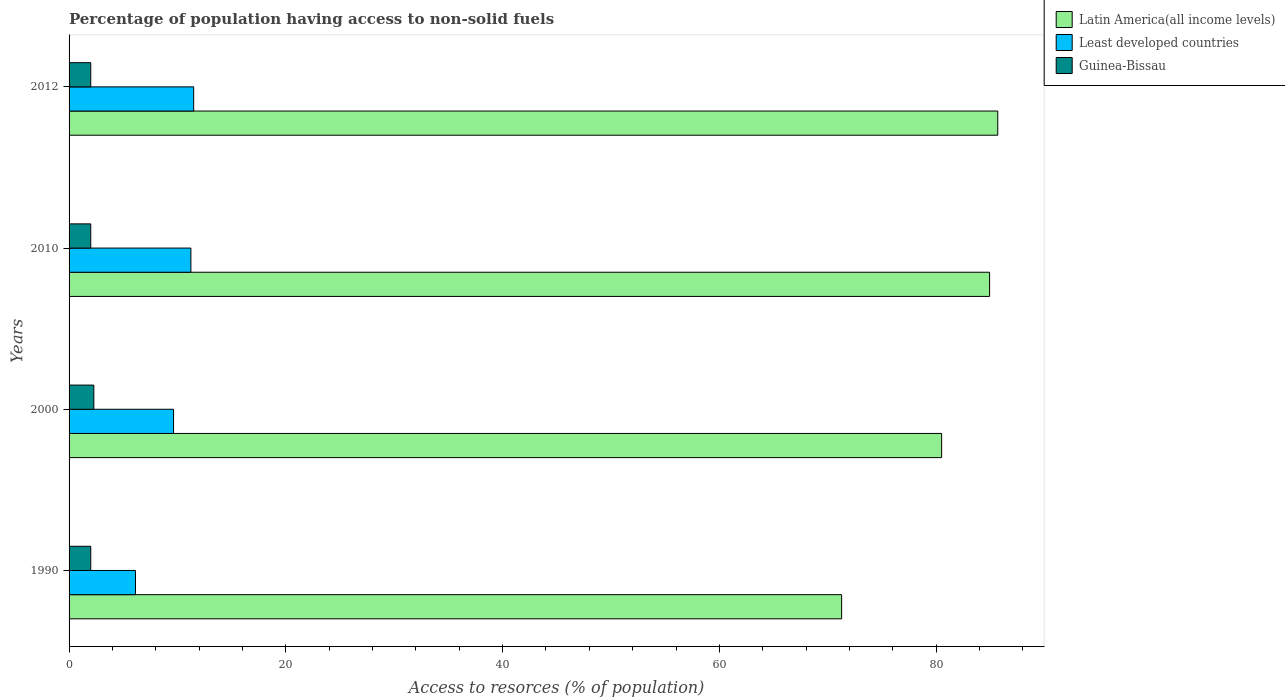How many groups of bars are there?
Keep it short and to the point. 4. Are the number of bars per tick equal to the number of legend labels?
Offer a very short reply. Yes. How many bars are there on the 3rd tick from the top?
Ensure brevity in your answer.  3. What is the label of the 2nd group of bars from the top?
Your answer should be compact. 2010. What is the percentage of population having access to non-solid fuels in Latin America(all income levels) in 2012?
Give a very brief answer. 85.68. Across all years, what is the maximum percentage of population having access to non-solid fuels in Least developed countries?
Your answer should be very brief. 11.5. Across all years, what is the minimum percentage of population having access to non-solid fuels in Least developed countries?
Offer a very short reply. 6.13. In which year was the percentage of population having access to non-solid fuels in Least developed countries minimum?
Your answer should be compact. 1990. What is the total percentage of population having access to non-solid fuels in Guinea-Bissau in the graph?
Make the answer very short. 8.28. What is the difference between the percentage of population having access to non-solid fuels in Latin America(all income levels) in 2010 and that in 2012?
Offer a terse response. -0.75. What is the difference between the percentage of population having access to non-solid fuels in Guinea-Bissau in 2000 and the percentage of population having access to non-solid fuels in Latin America(all income levels) in 2012?
Offer a terse response. -83.4. What is the average percentage of population having access to non-solid fuels in Guinea-Bissau per year?
Give a very brief answer. 2.07. In the year 2000, what is the difference between the percentage of population having access to non-solid fuels in Guinea-Bissau and percentage of population having access to non-solid fuels in Latin America(all income levels)?
Your response must be concise. -78.22. What is the ratio of the percentage of population having access to non-solid fuels in Latin America(all income levels) in 2010 to that in 2012?
Make the answer very short. 0.99. What is the difference between the highest and the second highest percentage of population having access to non-solid fuels in Latin America(all income levels)?
Offer a very short reply. 0.75. What is the difference between the highest and the lowest percentage of population having access to non-solid fuels in Least developed countries?
Your answer should be very brief. 5.37. Is the sum of the percentage of population having access to non-solid fuels in Least developed countries in 1990 and 2000 greater than the maximum percentage of population having access to non-solid fuels in Latin America(all income levels) across all years?
Provide a succinct answer. No. What does the 1st bar from the top in 2010 represents?
Make the answer very short. Guinea-Bissau. What does the 1st bar from the bottom in 2012 represents?
Ensure brevity in your answer.  Latin America(all income levels). How many bars are there?
Make the answer very short. 12. Where does the legend appear in the graph?
Your answer should be very brief. Top right. What is the title of the graph?
Provide a succinct answer. Percentage of population having access to non-solid fuels. Does "East Asia (developing only)" appear as one of the legend labels in the graph?
Make the answer very short. No. What is the label or title of the X-axis?
Your answer should be compact. Access to resorces (% of population). What is the label or title of the Y-axis?
Offer a very short reply. Years. What is the Access to resorces (% of population) in Latin America(all income levels) in 1990?
Offer a very short reply. 71.28. What is the Access to resorces (% of population) in Least developed countries in 1990?
Keep it short and to the point. 6.13. What is the Access to resorces (% of population) in Guinea-Bissau in 1990?
Ensure brevity in your answer.  2. What is the Access to resorces (% of population) in Latin America(all income levels) in 2000?
Provide a short and direct response. 80.51. What is the Access to resorces (% of population) of Least developed countries in 2000?
Give a very brief answer. 9.64. What is the Access to resorces (% of population) of Guinea-Bissau in 2000?
Offer a very short reply. 2.28. What is the Access to resorces (% of population) of Latin America(all income levels) in 2010?
Ensure brevity in your answer.  84.93. What is the Access to resorces (% of population) of Least developed countries in 2010?
Ensure brevity in your answer.  11.24. What is the Access to resorces (% of population) of Guinea-Bissau in 2010?
Provide a succinct answer. 2. What is the Access to resorces (% of population) in Latin America(all income levels) in 2012?
Offer a terse response. 85.68. What is the Access to resorces (% of population) of Least developed countries in 2012?
Provide a short and direct response. 11.5. What is the Access to resorces (% of population) of Guinea-Bissau in 2012?
Offer a terse response. 2. Across all years, what is the maximum Access to resorces (% of population) of Latin America(all income levels)?
Your response must be concise. 85.68. Across all years, what is the maximum Access to resorces (% of population) of Least developed countries?
Ensure brevity in your answer.  11.5. Across all years, what is the maximum Access to resorces (% of population) in Guinea-Bissau?
Keep it short and to the point. 2.28. Across all years, what is the minimum Access to resorces (% of population) in Latin America(all income levels)?
Ensure brevity in your answer.  71.28. Across all years, what is the minimum Access to resorces (% of population) of Least developed countries?
Offer a very short reply. 6.13. Across all years, what is the minimum Access to resorces (% of population) in Guinea-Bissau?
Keep it short and to the point. 2. What is the total Access to resorces (% of population) of Latin America(all income levels) in the graph?
Give a very brief answer. 322.4. What is the total Access to resorces (% of population) of Least developed countries in the graph?
Ensure brevity in your answer.  38.5. What is the total Access to resorces (% of population) in Guinea-Bissau in the graph?
Your answer should be compact. 8.28. What is the difference between the Access to resorces (% of population) of Latin America(all income levels) in 1990 and that in 2000?
Give a very brief answer. -9.23. What is the difference between the Access to resorces (% of population) in Least developed countries in 1990 and that in 2000?
Your response must be concise. -3.51. What is the difference between the Access to resorces (% of population) in Guinea-Bissau in 1990 and that in 2000?
Offer a very short reply. -0.28. What is the difference between the Access to resorces (% of population) of Latin America(all income levels) in 1990 and that in 2010?
Ensure brevity in your answer.  -13.65. What is the difference between the Access to resorces (% of population) of Least developed countries in 1990 and that in 2010?
Provide a short and direct response. -5.11. What is the difference between the Access to resorces (% of population) of Latin America(all income levels) in 1990 and that in 2012?
Offer a terse response. -14.41. What is the difference between the Access to resorces (% of population) of Least developed countries in 1990 and that in 2012?
Make the answer very short. -5.37. What is the difference between the Access to resorces (% of population) in Guinea-Bissau in 1990 and that in 2012?
Provide a short and direct response. 0. What is the difference between the Access to resorces (% of population) of Latin America(all income levels) in 2000 and that in 2010?
Provide a succinct answer. -4.43. What is the difference between the Access to resorces (% of population) of Least developed countries in 2000 and that in 2010?
Offer a terse response. -1.6. What is the difference between the Access to resorces (% of population) of Guinea-Bissau in 2000 and that in 2010?
Provide a short and direct response. 0.28. What is the difference between the Access to resorces (% of population) of Latin America(all income levels) in 2000 and that in 2012?
Ensure brevity in your answer.  -5.18. What is the difference between the Access to resorces (% of population) of Least developed countries in 2000 and that in 2012?
Give a very brief answer. -1.86. What is the difference between the Access to resorces (% of population) of Guinea-Bissau in 2000 and that in 2012?
Keep it short and to the point. 0.28. What is the difference between the Access to resorces (% of population) in Latin America(all income levels) in 2010 and that in 2012?
Offer a terse response. -0.75. What is the difference between the Access to resorces (% of population) of Least developed countries in 2010 and that in 2012?
Your answer should be very brief. -0.26. What is the difference between the Access to resorces (% of population) of Guinea-Bissau in 2010 and that in 2012?
Give a very brief answer. 0. What is the difference between the Access to resorces (% of population) in Latin America(all income levels) in 1990 and the Access to resorces (% of population) in Least developed countries in 2000?
Your answer should be compact. 61.64. What is the difference between the Access to resorces (% of population) in Latin America(all income levels) in 1990 and the Access to resorces (% of population) in Guinea-Bissau in 2000?
Offer a very short reply. 68.99. What is the difference between the Access to resorces (% of population) of Least developed countries in 1990 and the Access to resorces (% of population) of Guinea-Bissau in 2000?
Keep it short and to the point. 3.84. What is the difference between the Access to resorces (% of population) in Latin America(all income levels) in 1990 and the Access to resorces (% of population) in Least developed countries in 2010?
Provide a succinct answer. 60.04. What is the difference between the Access to resorces (% of population) of Latin America(all income levels) in 1990 and the Access to resorces (% of population) of Guinea-Bissau in 2010?
Give a very brief answer. 69.28. What is the difference between the Access to resorces (% of population) of Least developed countries in 1990 and the Access to resorces (% of population) of Guinea-Bissau in 2010?
Provide a succinct answer. 4.13. What is the difference between the Access to resorces (% of population) of Latin America(all income levels) in 1990 and the Access to resorces (% of population) of Least developed countries in 2012?
Provide a short and direct response. 59.78. What is the difference between the Access to resorces (% of population) in Latin America(all income levels) in 1990 and the Access to resorces (% of population) in Guinea-Bissau in 2012?
Provide a succinct answer. 69.28. What is the difference between the Access to resorces (% of population) in Least developed countries in 1990 and the Access to resorces (% of population) in Guinea-Bissau in 2012?
Your response must be concise. 4.13. What is the difference between the Access to resorces (% of population) of Latin America(all income levels) in 2000 and the Access to resorces (% of population) of Least developed countries in 2010?
Offer a very short reply. 69.27. What is the difference between the Access to resorces (% of population) of Latin America(all income levels) in 2000 and the Access to resorces (% of population) of Guinea-Bissau in 2010?
Keep it short and to the point. 78.51. What is the difference between the Access to resorces (% of population) of Least developed countries in 2000 and the Access to resorces (% of population) of Guinea-Bissau in 2010?
Keep it short and to the point. 7.64. What is the difference between the Access to resorces (% of population) in Latin America(all income levels) in 2000 and the Access to resorces (% of population) in Least developed countries in 2012?
Make the answer very short. 69.01. What is the difference between the Access to resorces (% of population) of Latin America(all income levels) in 2000 and the Access to resorces (% of population) of Guinea-Bissau in 2012?
Ensure brevity in your answer.  78.51. What is the difference between the Access to resorces (% of population) of Least developed countries in 2000 and the Access to resorces (% of population) of Guinea-Bissau in 2012?
Offer a terse response. 7.64. What is the difference between the Access to resorces (% of population) in Latin America(all income levels) in 2010 and the Access to resorces (% of population) in Least developed countries in 2012?
Make the answer very short. 73.44. What is the difference between the Access to resorces (% of population) in Latin America(all income levels) in 2010 and the Access to resorces (% of population) in Guinea-Bissau in 2012?
Offer a terse response. 82.93. What is the difference between the Access to resorces (% of population) in Least developed countries in 2010 and the Access to resorces (% of population) in Guinea-Bissau in 2012?
Your answer should be compact. 9.24. What is the average Access to resorces (% of population) of Latin America(all income levels) per year?
Keep it short and to the point. 80.6. What is the average Access to resorces (% of population) of Least developed countries per year?
Offer a very short reply. 9.63. What is the average Access to resorces (% of population) in Guinea-Bissau per year?
Keep it short and to the point. 2.07. In the year 1990, what is the difference between the Access to resorces (% of population) in Latin America(all income levels) and Access to resorces (% of population) in Least developed countries?
Offer a terse response. 65.15. In the year 1990, what is the difference between the Access to resorces (% of population) in Latin America(all income levels) and Access to resorces (% of population) in Guinea-Bissau?
Make the answer very short. 69.28. In the year 1990, what is the difference between the Access to resorces (% of population) of Least developed countries and Access to resorces (% of population) of Guinea-Bissau?
Your answer should be very brief. 4.13. In the year 2000, what is the difference between the Access to resorces (% of population) of Latin America(all income levels) and Access to resorces (% of population) of Least developed countries?
Offer a very short reply. 70.87. In the year 2000, what is the difference between the Access to resorces (% of population) of Latin America(all income levels) and Access to resorces (% of population) of Guinea-Bissau?
Offer a terse response. 78.22. In the year 2000, what is the difference between the Access to resorces (% of population) in Least developed countries and Access to resorces (% of population) in Guinea-Bissau?
Offer a very short reply. 7.36. In the year 2010, what is the difference between the Access to resorces (% of population) of Latin America(all income levels) and Access to resorces (% of population) of Least developed countries?
Ensure brevity in your answer.  73.69. In the year 2010, what is the difference between the Access to resorces (% of population) of Latin America(all income levels) and Access to resorces (% of population) of Guinea-Bissau?
Keep it short and to the point. 82.93. In the year 2010, what is the difference between the Access to resorces (% of population) in Least developed countries and Access to resorces (% of population) in Guinea-Bissau?
Give a very brief answer. 9.24. In the year 2012, what is the difference between the Access to resorces (% of population) in Latin America(all income levels) and Access to resorces (% of population) in Least developed countries?
Ensure brevity in your answer.  74.19. In the year 2012, what is the difference between the Access to resorces (% of population) in Latin America(all income levels) and Access to resorces (% of population) in Guinea-Bissau?
Ensure brevity in your answer.  83.68. In the year 2012, what is the difference between the Access to resorces (% of population) of Least developed countries and Access to resorces (% of population) of Guinea-Bissau?
Your answer should be compact. 9.5. What is the ratio of the Access to resorces (% of population) of Latin America(all income levels) in 1990 to that in 2000?
Your response must be concise. 0.89. What is the ratio of the Access to resorces (% of population) in Least developed countries in 1990 to that in 2000?
Your answer should be very brief. 0.64. What is the ratio of the Access to resorces (% of population) in Guinea-Bissau in 1990 to that in 2000?
Ensure brevity in your answer.  0.88. What is the ratio of the Access to resorces (% of population) of Latin America(all income levels) in 1990 to that in 2010?
Your response must be concise. 0.84. What is the ratio of the Access to resorces (% of population) in Least developed countries in 1990 to that in 2010?
Keep it short and to the point. 0.55. What is the ratio of the Access to resorces (% of population) of Latin America(all income levels) in 1990 to that in 2012?
Ensure brevity in your answer.  0.83. What is the ratio of the Access to resorces (% of population) of Least developed countries in 1990 to that in 2012?
Ensure brevity in your answer.  0.53. What is the ratio of the Access to resorces (% of population) of Guinea-Bissau in 1990 to that in 2012?
Your response must be concise. 1. What is the ratio of the Access to resorces (% of population) in Latin America(all income levels) in 2000 to that in 2010?
Offer a very short reply. 0.95. What is the ratio of the Access to resorces (% of population) in Least developed countries in 2000 to that in 2010?
Keep it short and to the point. 0.86. What is the ratio of the Access to resorces (% of population) of Guinea-Bissau in 2000 to that in 2010?
Your answer should be very brief. 1.14. What is the ratio of the Access to resorces (% of population) of Latin America(all income levels) in 2000 to that in 2012?
Offer a very short reply. 0.94. What is the ratio of the Access to resorces (% of population) of Least developed countries in 2000 to that in 2012?
Your response must be concise. 0.84. What is the ratio of the Access to resorces (% of population) in Guinea-Bissau in 2000 to that in 2012?
Ensure brevity in your answer.  1.14. What is the ratio of the Access to resorces (% of population) of Least developed countries in 2010 to that in 2012?
Ensure brevity in your answer.  0.98. What is the ratio of the Access to resorces (% of population) in Guinea-Bissau in 2010 to that in 2012?
Provide a succinct answer. 1. What is the difference between the highest and the second highest Access to resorces (% of population) in Latin America(all income levels)?
Give a very brief answer. 0.75. What is the difference between the highest and the second highest Access to resorces (% of population) in Least developed countries?
Your response must be concise. 0.26. What is the difference between the highest and the second highest Access to resorces (% of population) of Guinea-Bissau?
Give a very brief answer. 0.28. What is the difference between the highest and the lowest Access to resorces (% of population) in Latin America(all income levels)?
Ensure brevity in your answer.  14.41. What is the difference between the highest and the lowest Access to resorces (% of population) in Least developed countries?
Your response must be concise. 5.37. What is the difference between the highest and the lowest Access to resorces (% of population) in Guinea-Bissau?
Give a very brief answer. 0.28. 